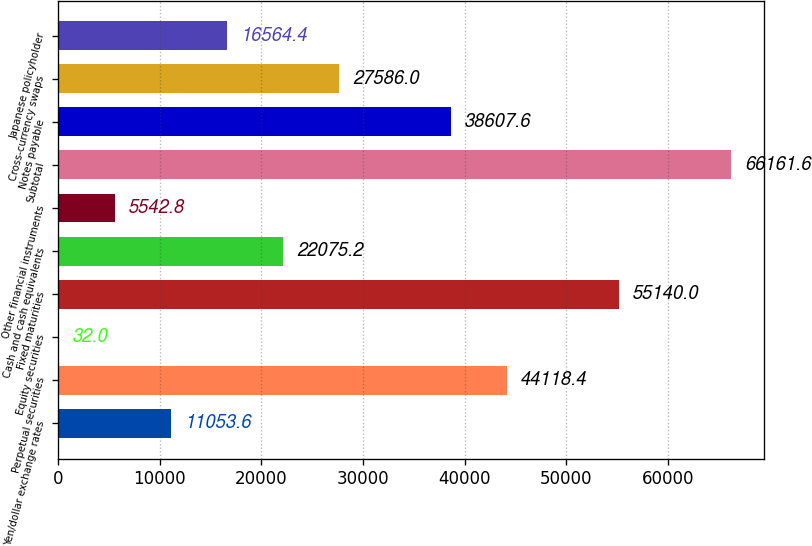<chart> <loc_0><loc_0><loc_500><loc_500><bar_chart><fcel>Yen/dollar exchange rates<fcel>Perpetual securities<fcel>Equity securities<fcel>Fixed maturities<fcel>Cash and cash equivalents<fcel>Other financial instruments<fcel>Subtotal<fcel>Notes payable<fcel>Cross-currency swaps<fcel>Japanese policyholder<nl><fcel>11053.6<fcel>44118.4<fcel>32<fcel>55140<fcel>22075.2<fcel>5542.8<fcel>66161.6<fcel>38607.6<fcel>27586<fcel>16564.4<nl></chart> 